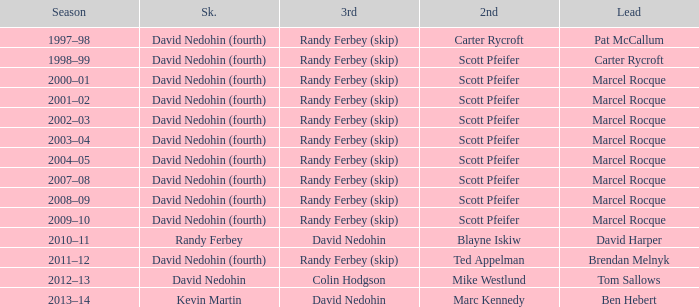Which Season has a Third of colin hodgson? 2012–13. 